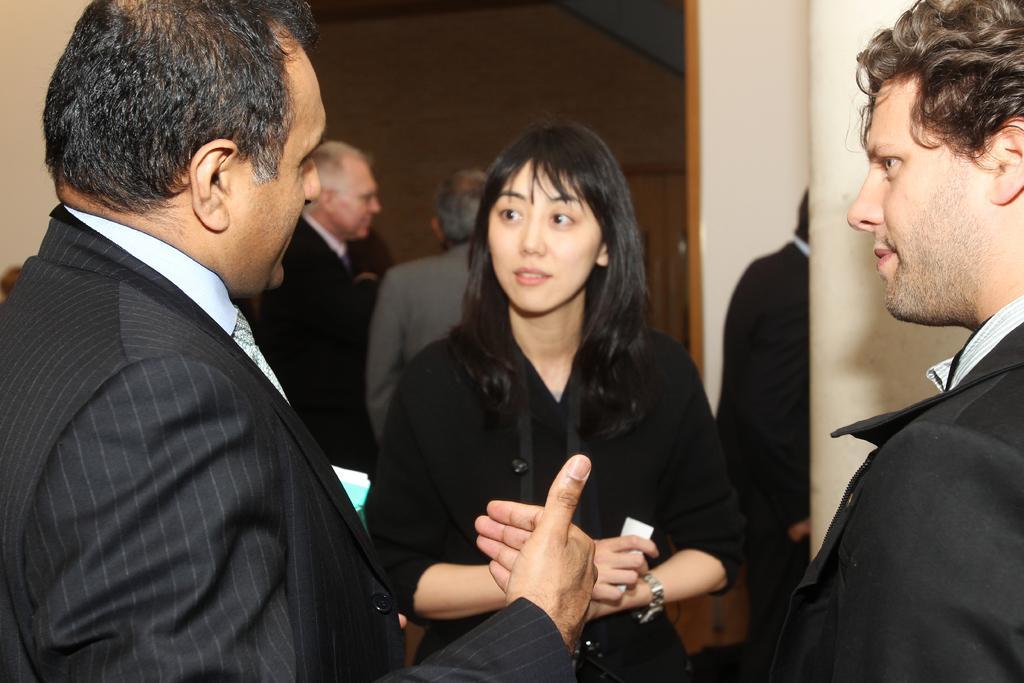Please provide a concise description of this image. In this picture I can see group of people standing, and in the background there is a wall. 